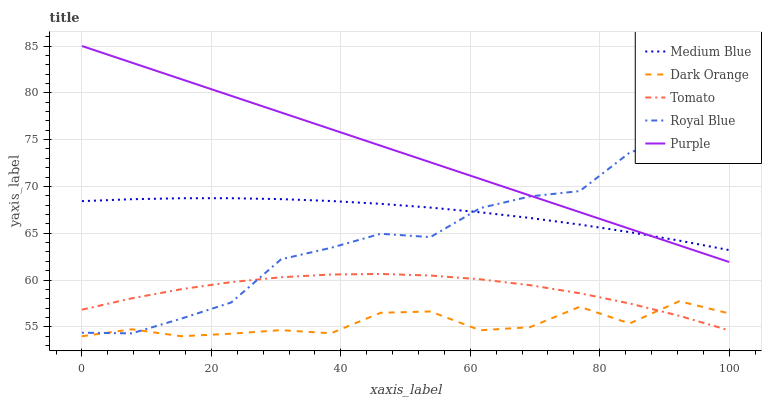Does Medium Blue have the minimum area under the curve?
Answer yes or no. No. Does Medium Blue have the maximum area under the curve?
Answer yes or no. No. Is Medium Blue the smoothest?
Answer yes or no. No. Is Medium Blue the roughest?
Answer yes or no. No. Does Medium Blue have the lowest value?
Answer yes or no. No. Does Medium Blue have the highest value?
Answer yes or no. No. Is Tomato less than Medium Blue?
Answer yes or no. Yes. Is Medium Blue greater than Dark Orange?
Answer yes or no. Yes. Does Tomato intersect Medium Blue?
Answer yes or no. No. 